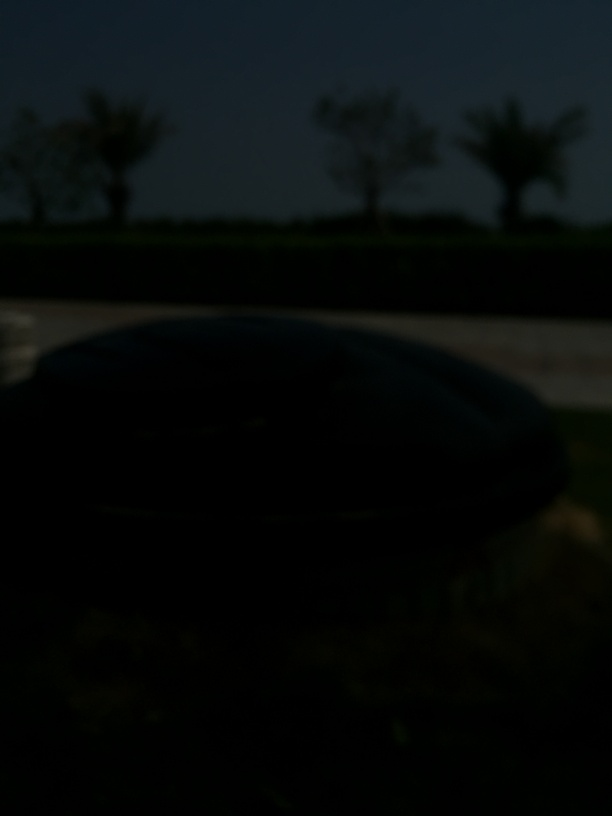What adjustments could improve the visibility of this photo? Increasing the exposure either in-camera, if the photo is yet to be taken, or through post-processing software can significantly improve the visibility. Brightness and contrast adjustments as well as shadow lifting may also reveal more details. 